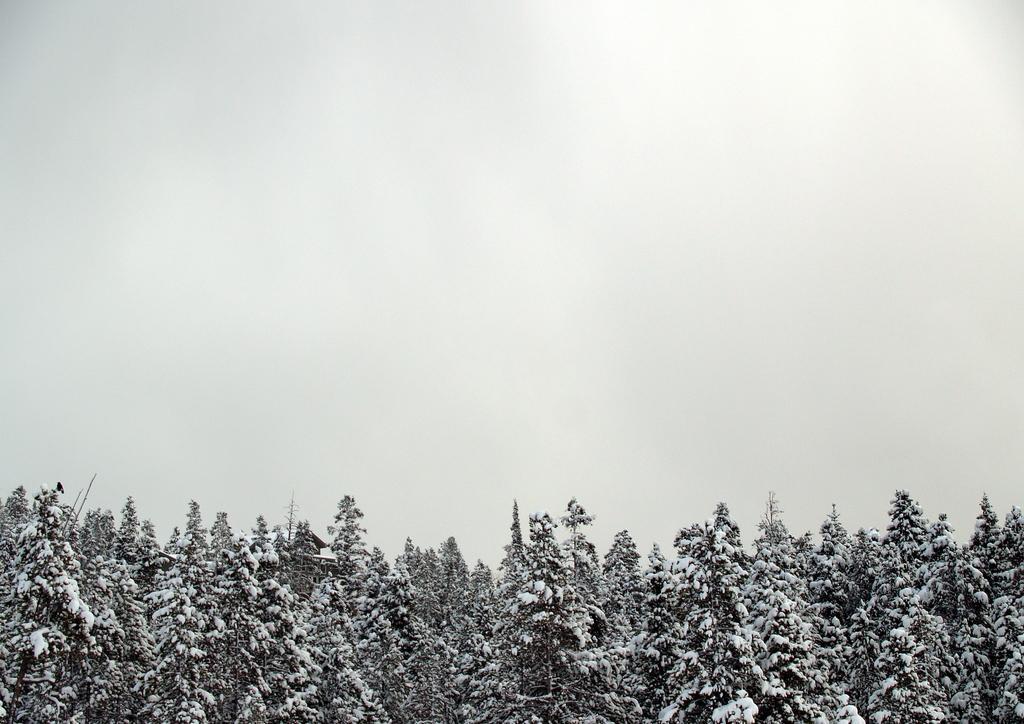Please provide a concise description of this image. At the down side these are the green trees, at the top it's a foggy sky. 